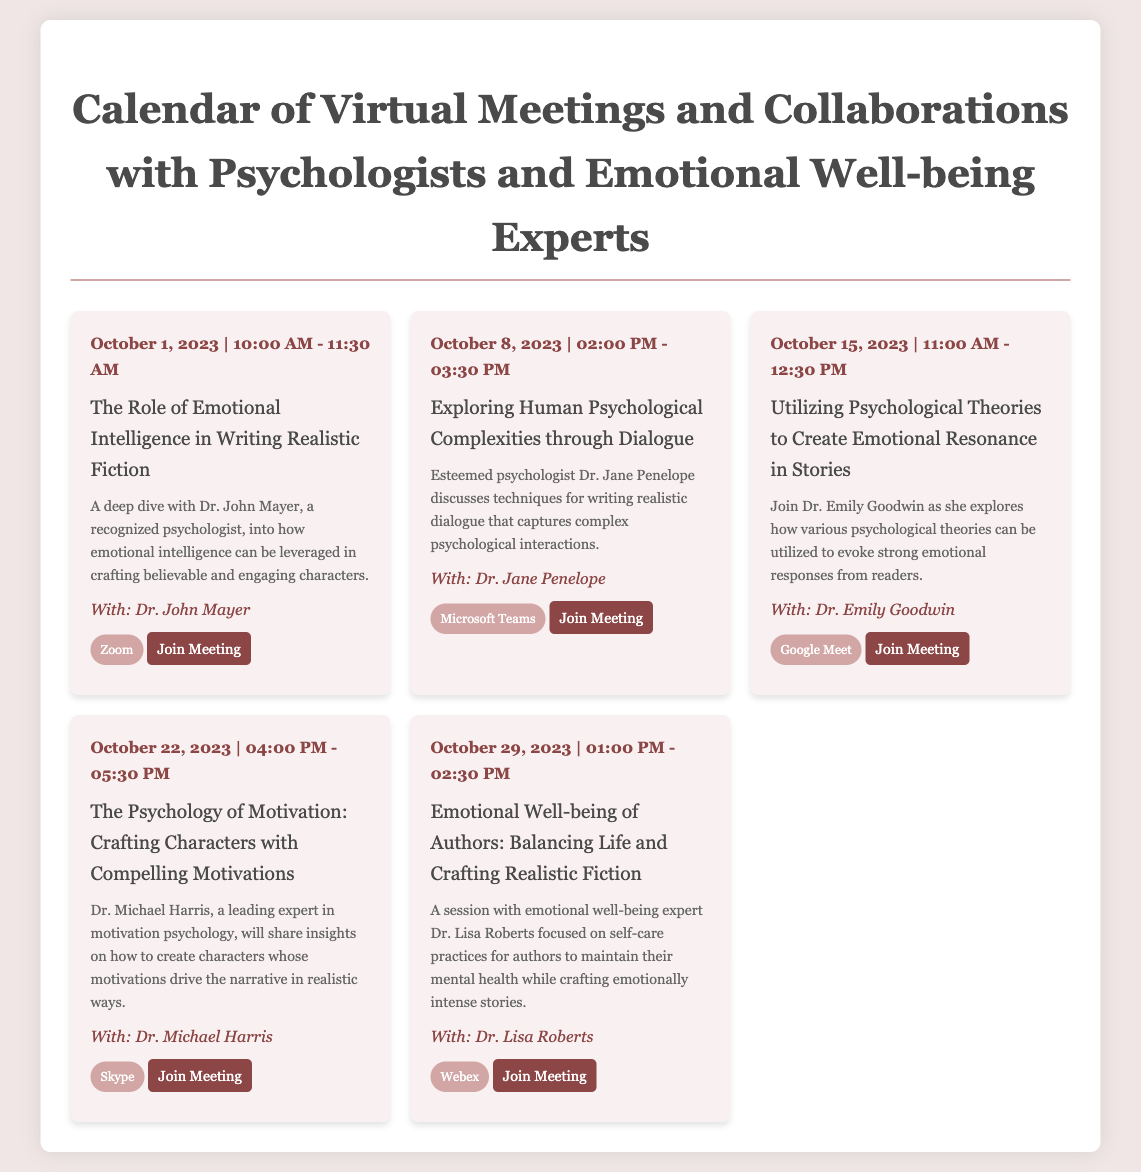What is the date of the first meeting? The first meeting is scheduled for October 1, 2023.
Answer: October 1, 2023 Who is the guest speaker for the session on emotional intelligence? The guest speaker for this session is Dr. John Mayer.
Answer: Dr. John Mayer What time does the meeting on psychological theories take place? The meeting on psychological theories takes place from 11:00 AM to 12:30 PM.
Answer: 11:00 AM - 12:30 PM How many meetings are scheduled in October 2023? There are a total of five meetings scheduled in October 2023.
Answer: Five Which platform is used for the meeting on emotional well-being of authors? The platform used for this meeting is Webex.
Answer: Webex What is the main focus of the meeting led by Dr. Michael Harris? The main focus is on crafting characters with compelling motivations.
Answer: Crafting characters with compelling motivations What common theme can be inferred from the meetings listed? The common theme is the integration of psychological principles in writing realistic fiction.
Answer: Psychological principles in writing What type of document is this? This document is a calendar for virtual meetings.
Answer: Calendar What is the link to join the meeting on October 8, 2023? The link to join this meeting is provided in the document.
Answer: https://teams.microsoft.com/l/meetup-join/19%3ameeting_NmYyYzZjYjktYzNkMy00Y2FhLThlZjMtNDhkMGM1NTBhYTZj%40thread.v2/0 